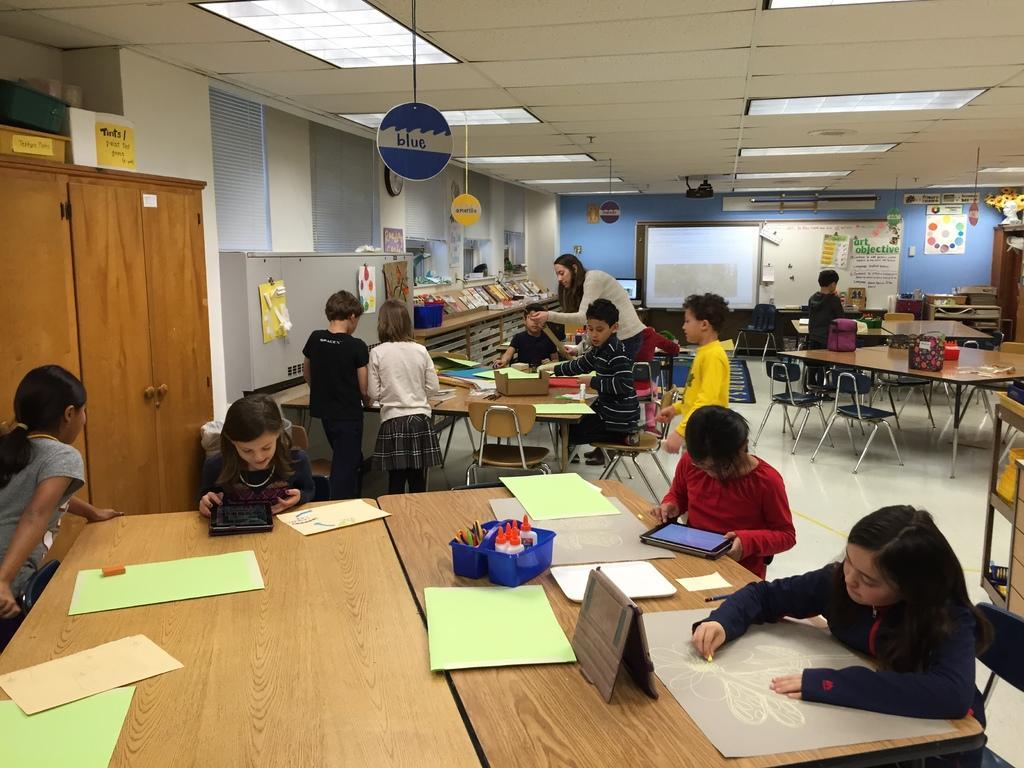Please provide a concise description of this image. In this picture we can see few people are sitting on the chairs. And this is the table, on the table there is a paper, tab, and a box. This is the floor and there is a cupboard. And even we can see a board here. And these are the lights. 